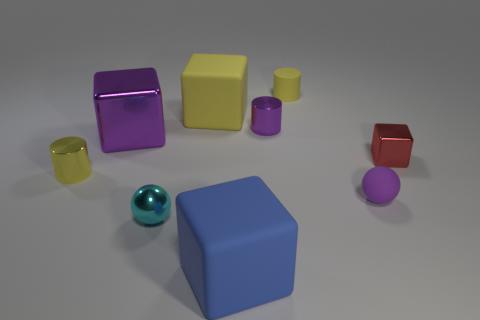Is the number of small red metallic objects less than the number of large red shiny things?
Provide a short and direct response. No. The blue object is what shape?
Offer a very short reply. Cube. There is a tiny metal cylinder in front of the tiny purple shiny cylinder; does it have the same color as the rubber cylinder?
Your answer should be very brief. Yes. What shape is the tiny thing that is right of the purple cylinder and to the left of the small rubber sphere?
Make the answer very short. Cylinder. What is the color of the tiny rubber thing that is in front of the small red metallic thing?
Your answer should be very brief. Purple. Are there any other things of the same color as the tiny cube?
Keep it short and to the point. No. Is the blue object the same size as the metallic ball?
Make the answer very short. No. What is the size of the block that is both left of the tiny red metallic thing and in front of the big purple thing?
Provide a succinct answer. Large. What number of red things have the same material as the small cyan thing?
Your answer should be compact. 1. There is a big thing that is the same color as the rubber ball; what is its shape?
Give a very brief answer. Cube. 